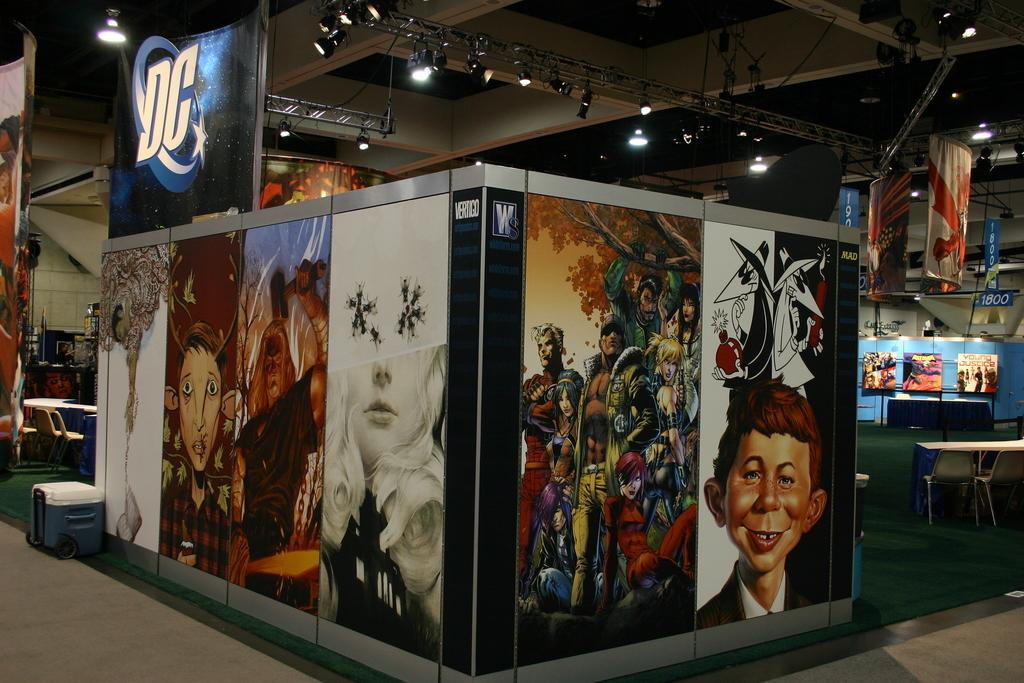What type of signage can be seen in the image? There are hoardings and banners in the image. What type of furniture is present in the image? There are tables and chairs in the image. What type of lighting is present in the image? There are lights in the image. What type of surface is visible in the image? There is a ceiling, a wall, and a floor in the image. What type of floor covering is present in the image? There is a carpet in the image. Are there any other objects present in the image? Yes, there are other objects in the image. Can you tell me how many branches are hanging from the ceiling in the image? There are no branches hanging from the ceiling in the image. What type of wind can be seen blowing through the room in the image? There is no wind present in the image. 